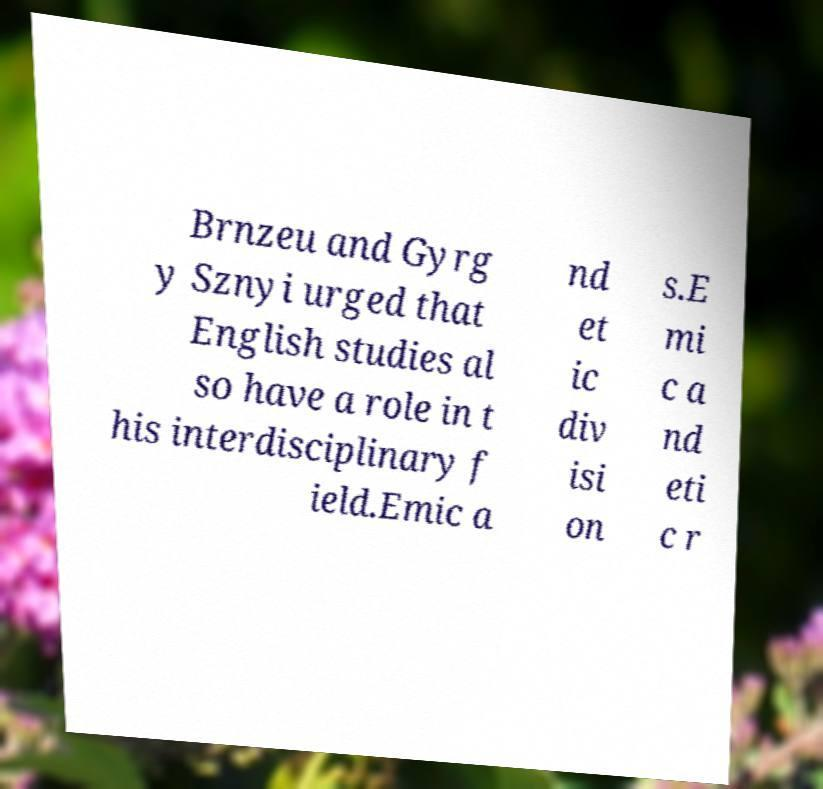I need the written content from this picture converted into text. Can you do that? Brnzeu and Gyrg y Sznyi urged that English studies al so have a role in t his interdisciplinary f ield.Emic a nd et ic div isi on s.E mi c a nd eti c r 